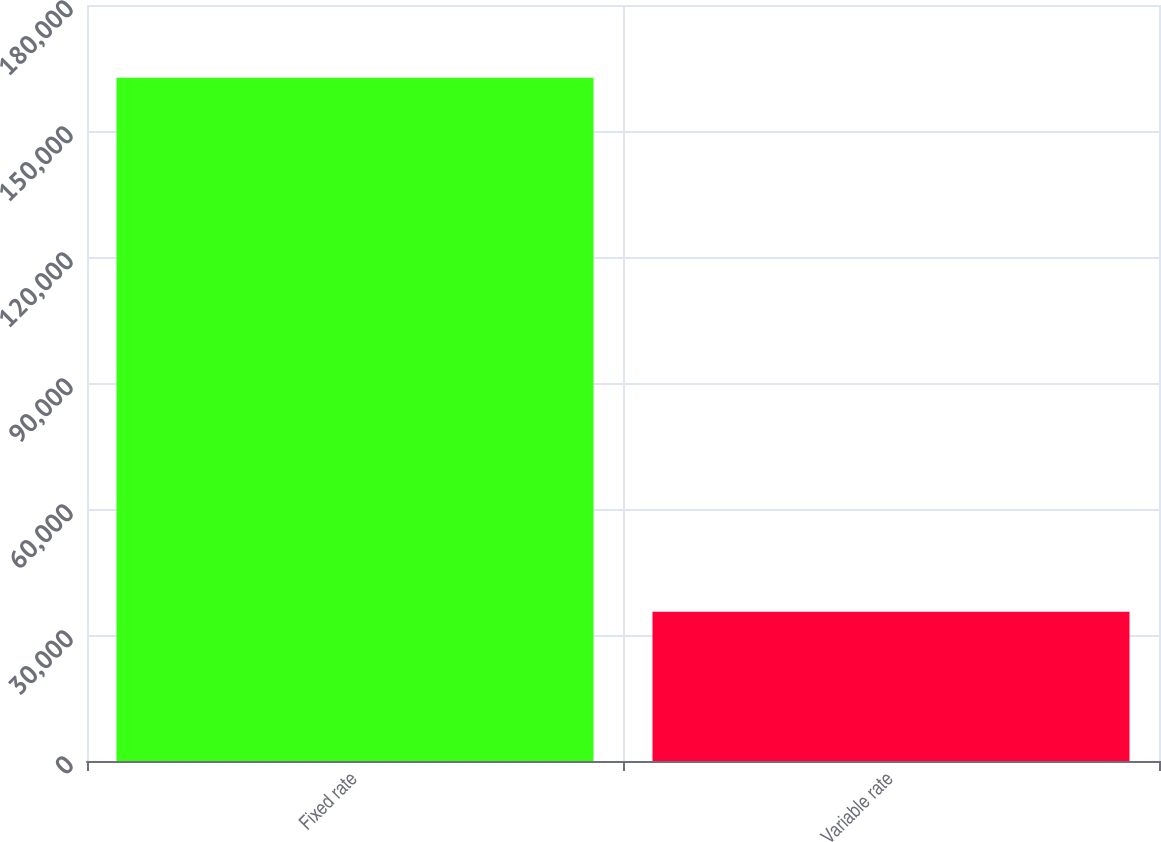Convert chart to OTSL. <chart><loc_0><loc_0><loc_500><loc_500><bar_chart><fcel>Fixed rate<fcel>Variable rate<nl><fcel>162699<fcel>35507<nl></chart> 